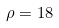<formula> <loc_0><loc_0><loc_500><loc_500>\rho = 1 8</formula> 